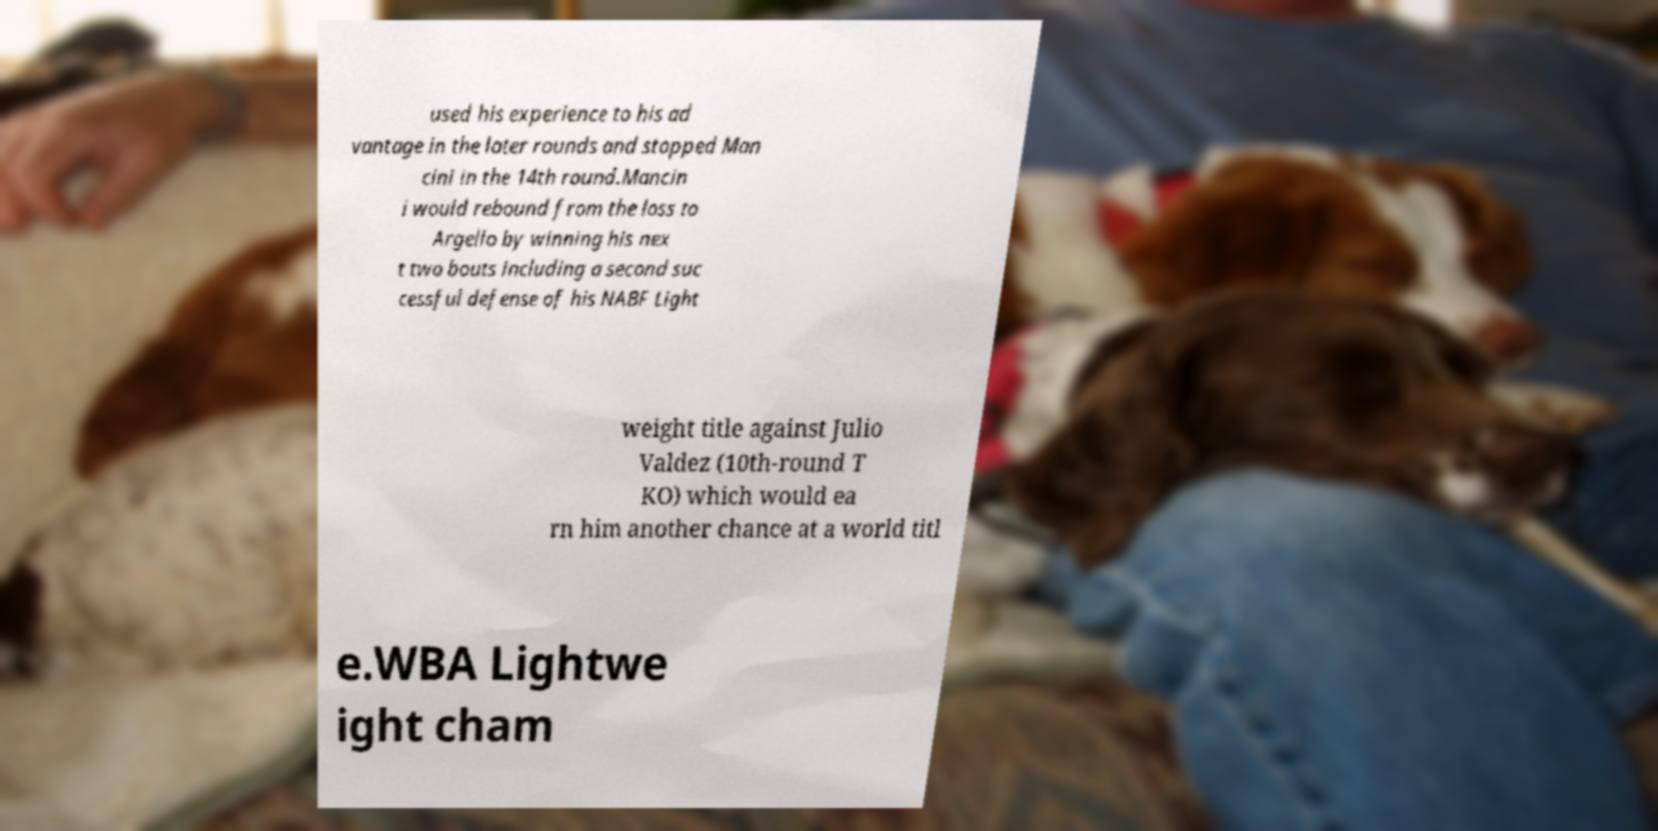Can you accurately transcribe the text from the provided image for me? used his experience to his ad vantage in the later rounds and stopped Man cini in the 14th round.Mancin i would rebound from the loss to Argello by winning his nex t two bouts including a second suc cessful defense of his NABF Light weight title against Julio Valdez (10th-round T KO) which would ea rn him another chance at a world titl e.WBA Lightwe ight cham 